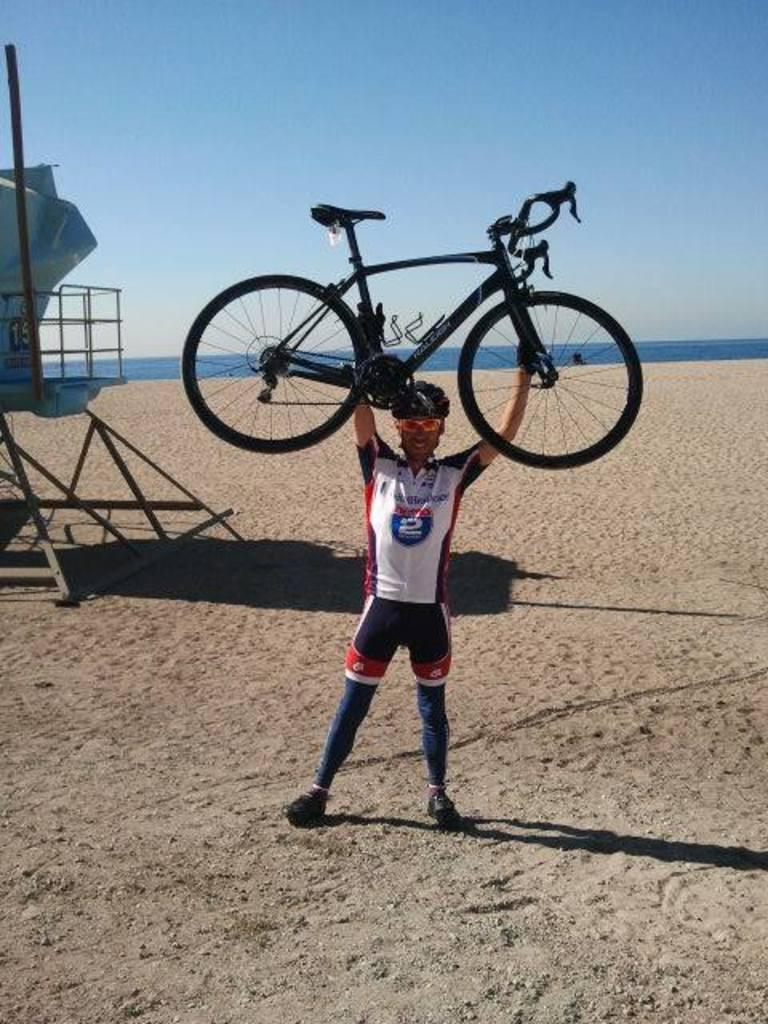<image>
Provide a brief description of the given image. the number 2 is on the shirt of the person 